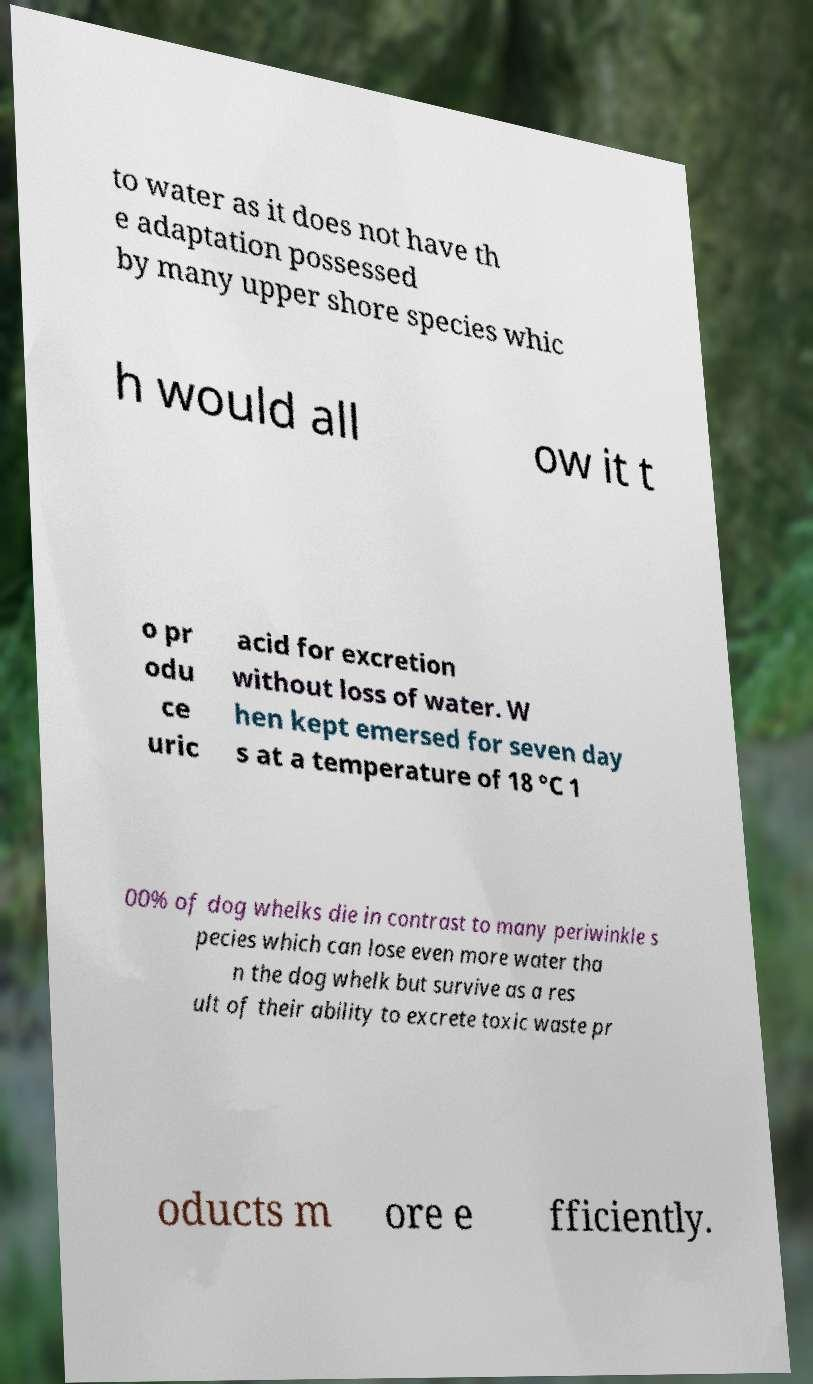Please identify and transcribe the text found in this image. to water as it does not have th e adaptation possessed by many upper shore species whic h would all ow it t o pr odu ce uric acid for excretion without loss of water. W hen kept emersed for seven day s at a temperature of 18 °C 1 00% of dog whelks die in contrast to many periwinkle s pecies which can lose even more water tha n the dog whelk but survive as a res ult of their ability to excrete toxic waste pr oducts m ore e fficiently. 